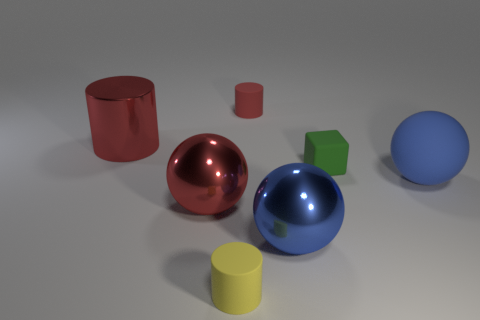Subtract all blue balls. How many balls are left? 1 Subtract all big red balls. How many balls are left? 2 Subtract all red cylinders. How many were subtracted if there are1red cylinders left? 1 Subtract all gray cylinders. Subtract all red balls. How many cylinders are left? 3 Subtract all red cylinders. How many blue spheres are left? 2 Subtract all big yellow shiny cubes. Subtract all small red cylinders. How many objects are left? 6 Add 7 matte cylinders. How many matte cylinders are left? 9 Add 6 red rubber objects. How many red rubber objects exist? 7 Add 1 small yellow matte cylinders. How many objects exist? 8 Subtract 0 yellow balls. How many objects are left? 7 